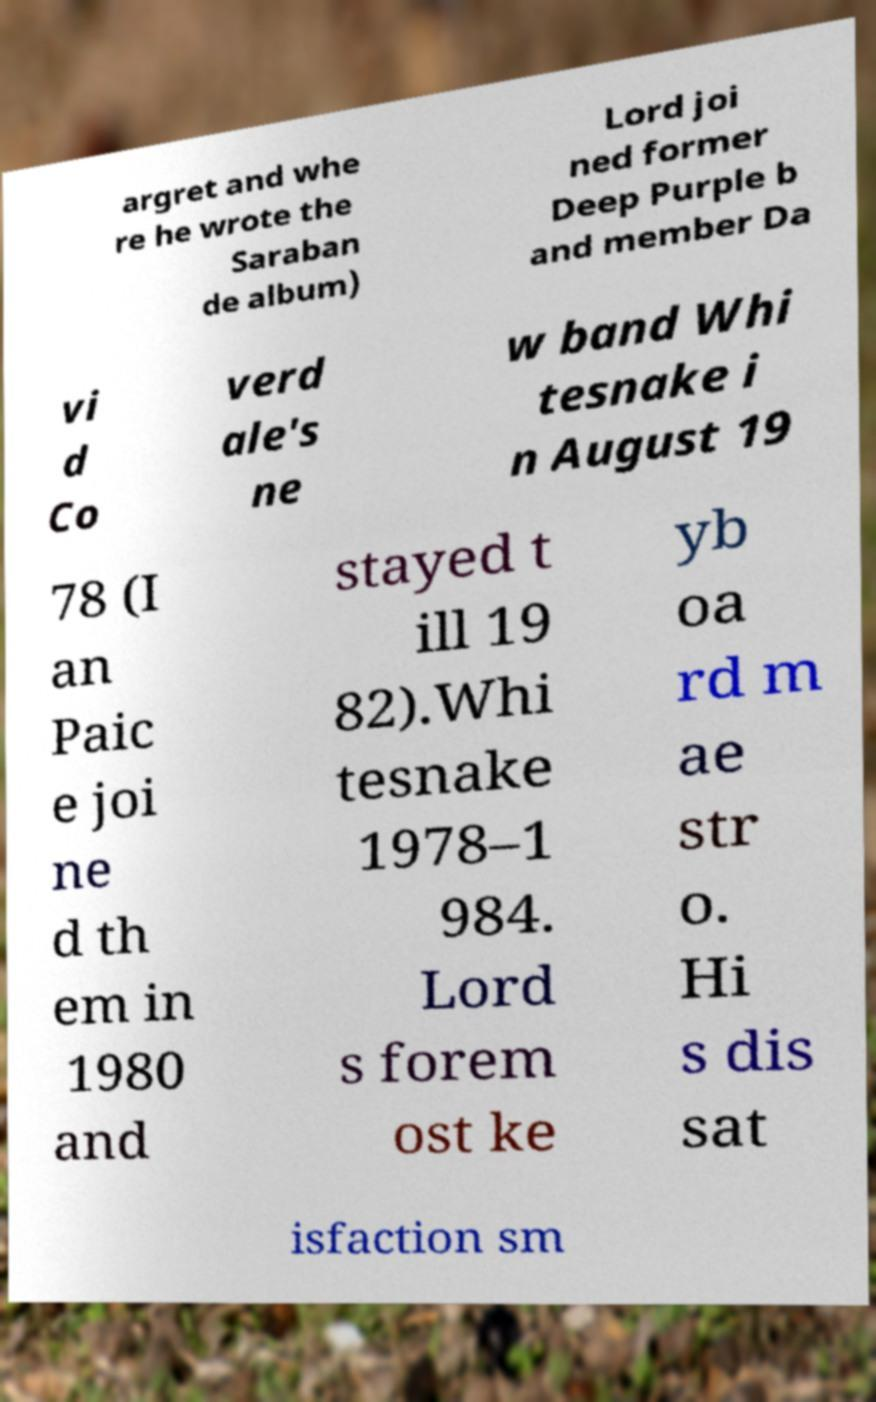What messages or text are displayed in this image? I need them in a readable, typed format. argret and whe re he wrote the Saraban de album) Lord joi ned former Deep Purple b and member Da vi d Co verd ale's ne w band Whi tesnake i n August 19 78 (I an Paic e joi ne d th em in 1980 and stayed t ill 19 82).Whi tesnake 1978–1 984. Lord s forem ost ke yb oa rd m ae str o. Hi s dis sat isfaction sm 